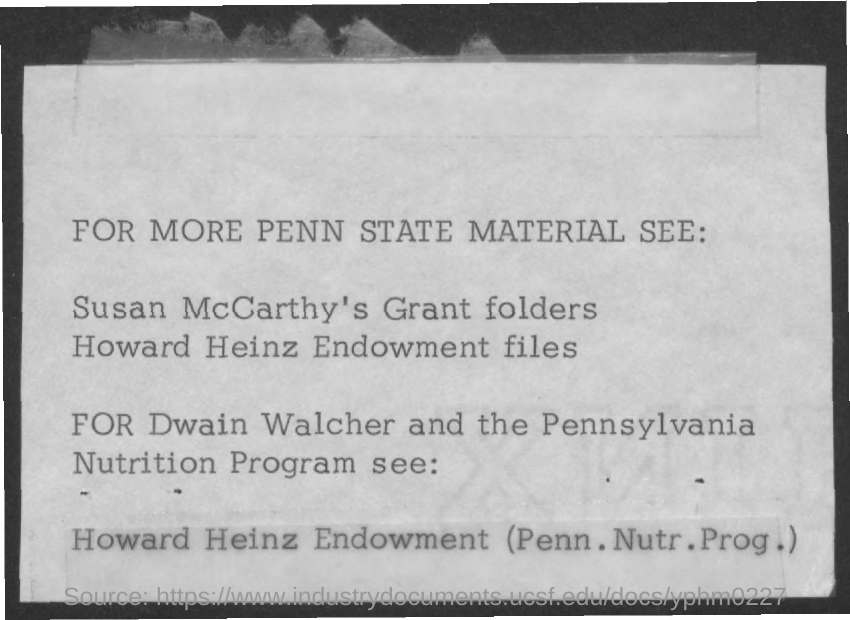Point out several critical features in this image. The first title in the document is: [insert title], and for additional Penn State-related material, refer to: [insert link or reference]. 